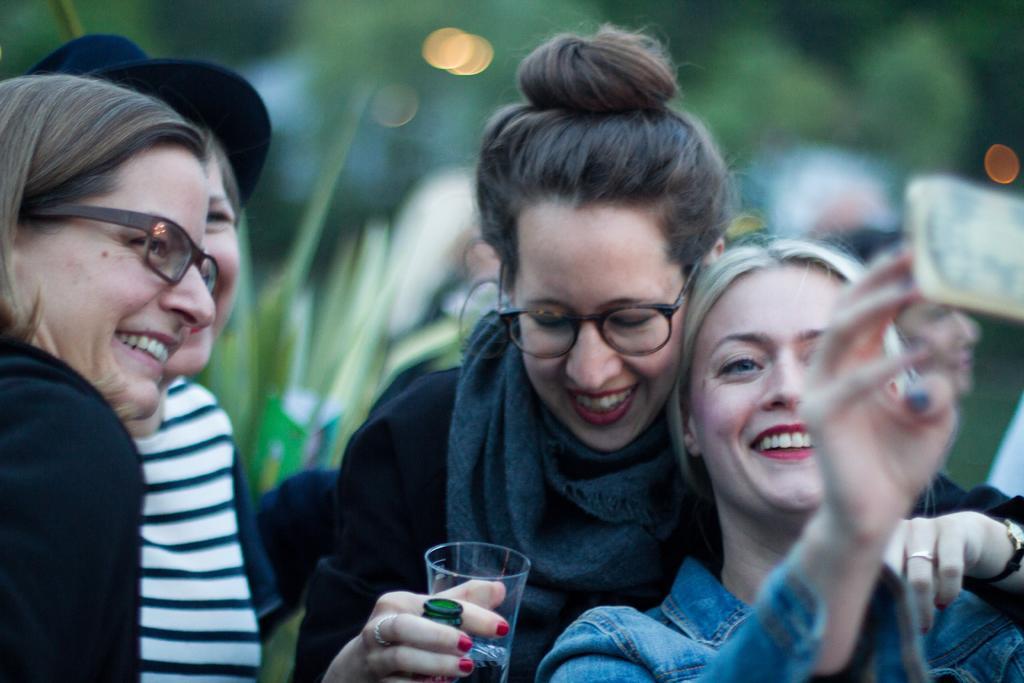Please provide a concise description of this image. Here we can see four persons and they are smiling. She is holding a glass with her hand. There is a blur background. 